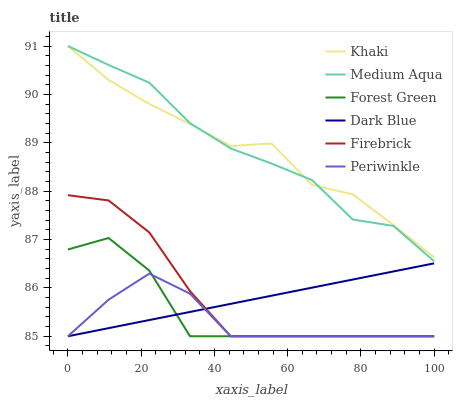Does Periwinkle have the minimum area under the curve?
Answer yes or no. Yes. Does Khaki have the maximum area under the curve?
Answer yes or no. Yes. Does Firebrick have the minimum area under the curve?
Answer yes or no. No. Does Firebrick have the maximum area under the curve?
Answer yes or no. No. Is Dark Blue the smoothest?
Answer yes or no. Yes. Is Forest Green the roughest?
Answer yes or no. Yes. Is Firebrick the smoothest?
Answer yes or no. No. Is Firebrick the roughest?
Answer yes or no. No. Does Firebrick have the lowest value?
Answer yes or no. Yes. Does Medium Aqua have the lowest value?
Answer yes or no. No. Does Khaki have the highest value?
Answer yes or no. Yes. Does Firebrick have the highest value?
Answer yes or no. No. Is Forest Green less than Medium Aqua?
Answer yes or no. Yes. Is Khaki greater than Dark Blue?
Answer yes or no. Yes. Does Firebrick intersect Forest Green?
Answer yes or no. Yes. Is Firebrick less than Forest Green?
Answer yes or no. No. Is Firebrick greater than Forest Green?
Answer yes or no. No. Does Forest Green intersect Medium Aqua?
Answer yes or no. No. 